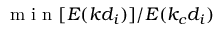Convert formula to latex. <formula><loc_0><loc_0><loc_500><loc_500>m i n [ E ( k d _ { i } ) ] / E ( k _ { c } d _ { i } )</formula> 